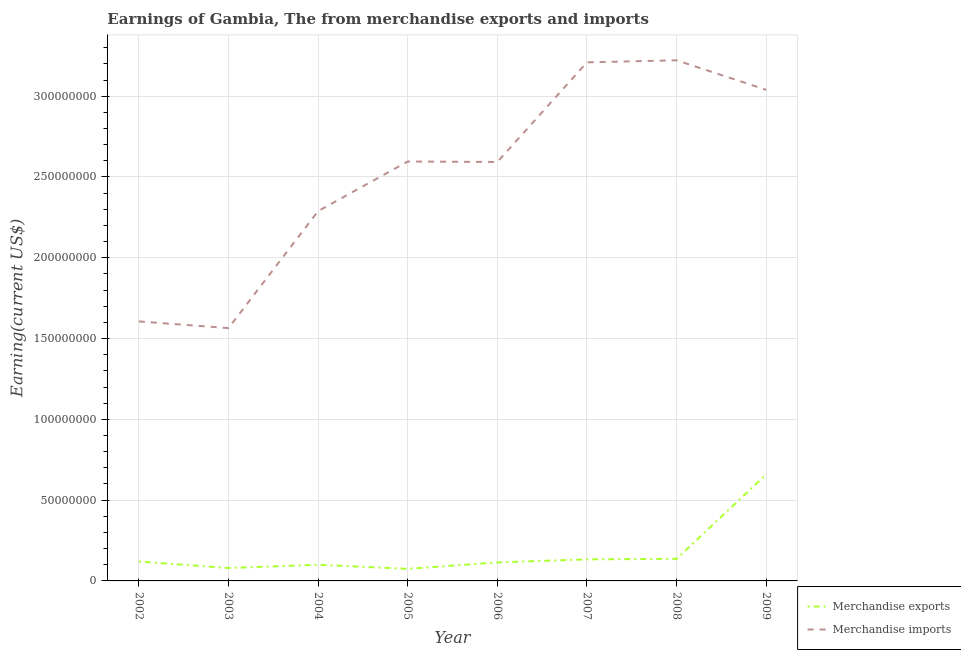Does the line corresponding to earnings from merchandise exports intersect with the line corresponding to earnings from merchandise imports?
Provide a short and direct response. No. What is the earnings from merchandise imports in 2006?
Your answer should be very brief. 2.59e+08. Across all years, what is the maximum earnings from merchandise imports?
Make the answer very short. 3.22e+08. Across all years, what is the minimum earnings from merchandise imports?
Offer a very short reply. 1.56e+08. In which year was the earnings from merchandise exports maximum?
Offer a terse response. 2009. In which year was the earnings from merchandise imports minimum?
Your response must be concise. 2003. What is the total earnings from merchandise imports in the graph?
Offer a terse response. 2.01e+09. What is the difference between the earnings from merchandise exports in 2004 and that in 2008?
Give a very brief answer. -3.67e+06. What is the difference between the earnings from merchandise imports in 2004 and the earnings from merchandise exports in 2008?
Provide a short and direct response. 2.15e+08. What is the average earnings from merchandise exports per year?
Make the answer very short. 1.77e+07. In the year 2004, what is the difference between the earnings from merchandise imports and earnings from merchandise exports?
Keep it short and to the point. 2.19e+08. What is the ratio of the earnings from merchandise exports in 2003 to that in 2004?
Ensure brevity in your answer.  0.8. Is the earnings from merchandise imports in 2008 less than that in 2009?
Make the answer very short. No. Is the difference between the earnings from merchandise exports in 2007 and 2008 greater than the difference between the earnings from merchandise imports in 2007 and 2008?
Offer a terse response. Yes. What is the difference between the highest and the second highest earnings from merchandise exports?
Your answer should be compact. 5.22e+07. What is the difference between the highest and the lowest earnings from merchandise exports?
Make the answer very short. 5.85e+07. In how many years, is the earnings from merchandise exports greater than the average earnings from merchandise exports taken over all years?
Give a very brief answer. 1. Does the earnings from merchandise imports monotonically increase over the years?
Your answer should be very brief. No. Is the earnings from merchandise exports strictly less than the earnings from merchandise imports over the years?
Keep it short and to the point. Yes. How many years are there in the graph?
Offer a very short reply. 8. How many legend labels are there?
Your response must be concise. 2. What is the title of the graph?
Provide a succinct answer. Earnings of Gambia, The from merchandise exports and imports. What is the label or title of the Y-axis?
Your answer should be compact. Earning(current US$). What is the Earning(current US$) in Merchandise exports in 2002?
Your response must be concise. 1.20e+07. What is the Earning(current US$) in Merchandise imports in 2002?
Provide a short and direct response. 1.61e+08. What is the Earning(current US$) in Merchandise imports in 2003?
Your answer should be very brief. 1.56e+08. What is the Earning(current US$) in Merchandise exports in 2004?
Your response must be concise. 1.00e+07. What is the Earning(current US$) in Merchandise imports in 2004?
Your answer should be compact. 2.29e+08. What is the Earning(current US$) of Merchandise exports in 2005?
Ensure brevity in your answer.  7.46e+06. What is the Earning(current US$) of Merchandise imports in 2005?
Give a very brief answer. 2.60e+08. What is the Earning(current US$) of Merchandise exports in 2006?
Provide a short and direct response. 1.15e+07. What is the Earning(current US$) of Merchandise imports in 2006?
Offer a terse response. 2.59e+08. What is the Earning(current US$) in Merchandise exports in 2007?
Your answer should be very brief. 1.33e+07. What is the Earning(current US$) of Merchandise imports in 2007?
Offer a terse response. 3.21e+08. What is the Earning(current US$) of Merchandise exports in 2008?
Provide a short and direct response. 1.37e+07. What is the Earning(current US$) of Merchandise imports in 2008?
Give a very brief answer. 3.22e+08. What is the Earning(current US$) in Merchandise exports in 2009?
Your answer should be compact. 6.59e+07. What is the Earning(current US$) in Merchandise imports in 2009?
Provide a short and direct response. 3.04e+08. Across all years, what is the maximum Earning(current US$) in Merchandise exports?
Your answer should be very brief. 6.59e+07. Across all years, what is the maximum Earning(current US$) in Merchandise imports?
Your answer should be very brief. 3.22e+08. Across all years, what is the minimum Earning(current US$) of Merchandise exports?
Offer a terse response. 7.46e+06. Across all years, what is the minimum Earning(current US$) of Merchandise imports?
Provide a succinct answer. 1.56e+08. What is the total Earning(current US$) of Merchandise exports in the graph?
Provide a short and direct response. 1.42e+08. What is the total Earning(current US$) in Merchandise imports in the graph?
Provide a short and direct response. 2.01e+09. What is the difference between the Earning(current US$) of Merchandise imports in 2002 and that in 2003?
Your answer should be very brief. 4.14e+06. What is the difference between the Earning(current US$) of Merchandise exports in 2002 and that in 2004?
Give a very brief answer. 2.00e+06. What is the difference between the Earning(current US$) in Merchandise imports in 2002 and that in 2004?
Provide a short and direct response. -6.83e+07. What is the difference between the Earning(current US$) in Merchandise exports in 2002 and that in 2005?
Offer a terse response. 4.54e+06. What is the difference between the Earning(current US$) in Merchandise imports in 2002 and that in 2005?
Make the answer very short. -9.90e+07. What is the difference between the Earning(current US$) of Merchandise exports in 2002 and that in 2006?
Make the answer very short. 5.37e+05. What is the difference between the Earning(current US$) in Merchandise imports in 2002 and that in 2006?
Make the answer very short. -9.87e+07. What is the difference between the Earning(current US$) in Merchandise exports in 2002 and that in 2007?
Ensure brevity in your answer.  -1.34e+06. What is the difference between the Earning(current US$) of Merchandise imports in 2002 and that in 2007?
Make the answer very short. -1.60e+08. What is the difference between the Earning(current US$) in Merchandise exports in 2002 and that in 2008?
Give a very brief answer. -1.67e+06. What is the difference between the Earning(current US$) of Merchandise imports in 2002 and that in 2008?
Offer a very short reply. -1.62e+08. What is the difference between the Earning(current US$) of Merchandise exports in 2002 and that in 2009?
Your answer should be very brief. -5.39e+07. What is the difference between the Earning(current US$) of Merchandise imports in 2002 and that in 2009?
Offer a very short reply. -1.43e+08. What is the difference between the Earning(current US$) in Merchandise exports in 2003 and that in 2004?
Provide a short and direct response. -2.00e+06. What is the difference between the Earning(current US$) in Merchandise imports in 2003 and that in 2004?
Give a very brief answer. -7.24e+07. What is the difference between the Earning(current US$) in Merchandise exports in 2003 and that in 2005?
Offer a terse response. 5.37e+05. What is the difference between the Earning(current US$) of Merchandise imports in 2003 and that in 2005?
Your response must be concise. -1.03e+08. What is the difference between the Earning(current US$) in Merchandise exports in 2003 and that in 2006?
Make the answer very short. -3.46e+06. What is the difference between the Earning(current US$) of Merchandise imports in 2003 and that in 2006?
Provide a succinct answer. -1.03e+08. What is the difference between the Earning(current US$) in Merchandise exports in 2003 and that in 2007?
Your answer should be very brief. -5.34e+06. What is the difference between the Earning(current US$) in Merchandise imports in 2003 and that in 2007?
Keep it short and to the point. -1.64e+08. What is the difference between the Earning(current US$) in Merchandise exports in 2003 and that in 2008?
Offer a terse response. -5.67e+06. What is the difference between the Earning(current US$) of Merchandise imports in 2003 and that in 2008?
Your response must be concise. -1.66e+08. What is the difference between the Earning(current US$) in Merchandise exports in 2003 and that in 2009?
Your answer should be very brief. -5.79e+07. What is the difference between the Earning(current US$) in Merchandise imports in 2003 and that in 2009?
Give a very brief answer. -1.47e+08. What is the difference between the Earning(current US$) of Merchandise exports in 2004 and that in 2005?
Your answer should be very brief. 2.54e+06. What is the difference between the Earning(current US$) of Merchandise imports in 2004 and that in 2005?
Ensure brevity in your answer.  -3.07e+07. What is the difference between the Earning(current US$) of Merchandise exports in 2004 and that in 2006?
Keep it short and to the point. -1.46e+06. What is the difference between the Earning(current US$) in Merchandise imports in 2004 and that in 2006?
Your response must be concise. -3.04e+07. What is the difference between the Earning(current US$) in Merchandise exports in 2004 and that in 2007?
Give a very brief answer. -3.34e+06. What is the difference between the Earning(current US$) of Merchandise imports in 2004 and that in 2007?
Offer a very short reply. -9.21e+07. What is the difference between the Earning(current US$) of Merchandise exports in 2004 and that in 2008?
Your response must be concise. -3.67e+06. What is the difference between the Earning(current US$) in Merchandise imports in 2004 and that in 2008?
Offer a terse response. -9.33e+07. What is the difference between the Earning(current US$) of Merchandise exports in 2004 and that in 2009?
Keep it short and to the point. -5.59e+07. What is the difference between the Earning(current US$) of Merchandise imports in 2004 and that in 2009?
Your answer should be compact. -7.51e+07. What is the difference between the Earning(current US$) in Merchandise exports in 2005 and that in 2006?
Your answer should be compact. -4.00e+06. What is the difference between the Earning(current US$) of Merchandise imports in 2005 and that in 2006?
Offer a terse response. 2.91e+05. What is the difference between the Earning(current US$) of Merchandise exports in 2005 and that in 2007?
Offer a terse response. -5.87e+06. What is the difference between the Earning(current US$) of Merchandise imports in 2005 and that in 2007?
Keep it short and to the point. -6.14e+07. What is the difference between the Earning(current US$) in Merchandise exports in 2005 and that in 2008?
Your answer should be very brief. -6.21e+06. What is the difference between the Earning(current US$) in Merchandise imports in 2005 and that in 2008?
Make the answer very short. -6.26e+07. What is the difference between the Earning(current US$) of Merchandise exports in 2005 and that in 2009?
Make the answer very short. -5.85e+07. What is the difference between the Earning(current US$) in Merchandise imports in 2005 and that in 2009?
Keep it short and to the point. -4.44e+07. What is the difference between the Earning(current US$) in Merchandise exports in 2006 and that in 2007?
Ensure brevity in your answer.  -1.87e+06. What is the difference between the Earning(current US$) of Merchandise imports in 2006 and that in 2007?
Provide a succinct answer. -6.17e+07. What is the difference between the Earning(current US$) of Merchandise exports in 2006 and that in 2008?
Give a very brief answer. -2.21e+06. What is the difference between the Earning(current US$) of Merchandise imports in 2006 and that in 2008?
Ensure brevity in your answer.  -6.29e+07. What is the difference between the Earning(current US$) of Merchandise exports in 2006 and that in 2009?
Offer a very short reply. -5.45e+07. What is the difference between the Earning(current US$) in Merchandise imports in 2006 and that in 2009?
Make the answer very short. -4.47e+07. What is the difference between the Earning(current US$) of Merchandise exports in 2007 and that in 2008?
Your answer should be compact. -3.33e+05. What is the difference between the Earning(current US$) in Merchandise imports in 2007 and that in 2008?
Make the answer very short. -1.27e+06. What is the difference between the Earning(current US$) in Merchandise exports in 2007 and that in 2009?
Make the answer very short. -5.26e+07. What is the difference between the Earning(current US$) in Merchandise imports in 2007 and that in 2009?
Offer a terse response. 1.70e+07. What is the difference between the Earning(current US$) of Merchandise exports in 2008 and that in 2009?
Ensure brevity in your answer.  -5.22e+07. What is the difference between the Earning(current US$) of Merchandise imports in 2008 and that in 2009?
Offer a very short reply. 1.83e+07. What is the difference between the Earning(current US$) of Merchandise exports in 2002 and the Earning(current US$) of Merchandise imports in 2003?
Provide a short and direct response. -1.44e+08. What is the difference between the Earning(current US$) in Merchandise exports in 2002 and the Earning(current US$) in Merchandise imports in 2004?
Offer a terse response. -2.17e+08. What is the difference between the Earning(current US$) of Merchandise exports in 2002 and the Earning(current US$) of Merchandise imports in 2005?
Make the answer very short. -2.48e+08. What is the difference between the Earning(current US$) in Merchandise exports in 2002 and the Earning(current US$) in Merchandise imports in 2006?
Provide a short and direct response. -2.47e+08. What is the difference between the Earning(current US$) in Merchandise exports in 2002 and the Earning(current US$) in Merchandise imports in 2007?
Offer a terse response. -3.09e+08. What is the difference between the Earning(current US$) in Merchandise exports in 2002 and the Earning(current US$) in Merchandise imports in 2008?
Give a very brief answer. -3.10e+08. What is the difference between the Earning(current US$) of Merchandise exports in 2002 and the Earning(current US$) of Merchandise imports in 2009?
Provide a short and direct response. -2.92e+08. What is the difference between the Earning(current US$) of Merchandise exports in 2003 and the Earning(current US$) of Merchandise imports in 2004?
Provide a succinct answer. -2.21e+08. What is the difference between the Earning(current US$) of Merchandise exports in 2003 and the Earning(current US$) of Merchandise imports in 2005?
Give a very brief answer. -2.52e+08. What is the difference between the Earning(current US$) of Merchandise exports in 2003 and the Earning(current US$) of Merchandise imports in 2006?
Offer a terse response. -2.51e+08. What is the difference between the Earning(current US$) of Merchandise exports in 2003 and the Earning(current US$) of Merchandise imports in 2007?
Give a very brief answer. -3.13e+08. What is the difference between the Earning(current US$) of Merchandise exports in 2003 and the Earning(current US$) of Merchandise imports in 2008?
Your response must be concise. -3.14e+08. What is the difference between the Earning(current US$) of Merchandise exports in 2003 and the Earning(current US$) of Merchandise imports in 2009?
Provide a short and direct response. -2.96e+08. What is the difference between the Earning(current US$) of Merchandise exports in 2004 and the Earning(current US$) of Merchandise imports in 2005?
Offer a very short reply. -2.50e+08. What is the difference between the Earning(current US$) of Merchandise exports in 2004 and the Earning(current US$) of Merchandise imports in 2006?
Give a very brief answer. -2.49e+08. What is the difference between the Earning(current US$) of Merchandise exports in 2004 and the Earning(current US$) of Merchandise imports in 2007?
Offer a terse response. -3.11e+08. What is the difference between the Earning(current US$) in Merchandise exports in 2004 and the Earning(current US$) in Merchandise imports in 2008?
Your answer should be compact. -3.12e+08. What is the difference between the Earning(current US$) in Merchandise exports in 2004 and the Earning(current US$) in Merchandise imports in 2009?
Your answer should be very brief. -2.94e+08. What is the difference between the Earning(current US$) of Merchandise exports in 2005 and the Earning(current US$) of Merchandise imports in 2006?
Offer a very short reply. -2.52e+08. What is the difference between the Earning(current US$) of Merchandise exports in 2005 and the Earning(current US$) of Merchandise imports in 2007?
Keep it short and to the point. -3.13e+08. What is the difference between the Earning(current US$) in Merchandise exports in 2005 and the Earning(current US$) in Merchandise imports in 2008?
Keep it short and to the point. -3.15e+08. What is the difference between the Earning(current US$) in Merchandise exports in 2005 and the Earning(current US$) in Merchandise imports in 2009?
Offer a very short reply. -2.96e+08. What is the difference between the Earning(current US$) of Merchandise exports in 2006 and the Earning(current US$) of Merchandise imports in 2007?
Provide a succinct answer. -3.09e+08. What is the difference between the Earning(current US$) in Merchandise exports in 2006 and the Earning(current US$) in Merchandise imports in 2008?
Make the answer very short. -3.11e+08. What is the difference between the Earning(current US$) in Merchandise exports in 2006 and the Earning(current US$) in Merchandise imports in 2009?
Make the answer very short. -2.92e+08. What is the difference between the Earning(current US$) of Merchandise exports in 2007 and the Earning(current US$) of Merchandise imports in 2008?
Keep it short and to the point. -3.09e+08. What is the difference between the Earning(current US$) in Merchandise exports in 2007 and the Earning(current US$) in Merchandise imports in 2009?
Your answer should be very brief. -2.91e+08. What is the difference between the Earning(current US$) of Merchandise exports in 2008 and the Earning(current US$) of Merchandise imports in 2009?
Your answer should be very brief. -2.90e+08. What is the average Earning(current US$) of Merchandise exports per year?
Make the answer very short. 1.77e+07. What is the average Earning(current US$) in Merchandise imports per year?
Make the answer very short. 2.51e+08. In the year 2002, what is the difference between the Earning(current US$) in Merchandise exports and Earning(current US$) in Merchandise imports?
Ensure brevity in your answer.  -1.49e+08. In the year 2003, what is the difference between the Earning(current US$) of Merchandise exports and Earning(current US$) of Merchandise imports?
Your answer should be compact. -1.48e+08. In the year 2004, what is the difference between the Earning(current US$) of Merchandise exports and Earning(current US$) of Merchandise imports?
Offer a very short reply. -2.19e+08. In the year 2005, what is the difference between the Earning(current US$) in Merchandise exports and Earning(current US$) in Merchandise imports?
Provide a succinct answer. -2.52e+08. In the year 2006, what is the difference between the Earning(current US$) in Merchandise exports and Earning(current US$) in Merchandise imports?
Provide a succinct answer. -2.48e+08. In the year 2007, what is the difference between the Earning(current US$) of Merchandise exports and Earning(current US$) of Merchandise imports?
Your answer should be compact. -3.08e+08. In the year 2008, what is the difference between the Earning(current US$) in Merchandise exports and Earning(current US$) in Merchandise imports?
Offer a terse response. -3.09e+08. In the year 2009, what is the difference between the Earning(current US$) of Merchandise exports and Earning(current US$) of Merchandise imports?
Make the answer very short. -2.38e+08. What is the ratio of the Earning(current US$) of Merchandise exports in 2002 to that in 2003?
Provide a short and direct response. 1.5. What is the ratio of the Earning(current US$) in Merchandise imports in 2002 to that in 2003?
Make the answer very short. 1.03. What is the ratio of the Earning(current US$) of Merchandise exports in 2002 to that in 2004?
Offer a terse response. 1.2. What is the ratio of the Earning(current US$) of Merchandise imports in 2002 to that in 2004?
Make the answer very short. 0.7. What is the ratio of the Earning(current US$) in Merchandise exports in 2002 to that in 2005?
Make the answer very short. 1.61. What is the ratio of the Earning(current US$) in Merchandise imports in 2002 to that in 2005?
Give a very brief answer. 0.62. What is the ratio of the Earning(current US$) of Merchandise exports in 2002 to that in 2006?
Offer a very short reply. 1.05. What is the ratio of the Earning(current US$) of Merchandise imports in 2002 to that in 2006?
Provide a succinct answer. 0.62. What is the ratio of the Earning(current US$) of Merchandise exports in 2002 to that in 2007?
Your answer should be very brief. 0.9. What is the ratio of the Earning(current US$) in Merchandise imports in 2002 to that in 2007?
Provide a succinct answer. 0.5. What is the ratio of the Earning(current US$) in Merchandise exports in 2002 to that in 2008?
Offer a terse response. 0.88. What is the ratio of the Earning(current US$) of Merchandise imports in 2002 to that in 2008?
Keep it short and to the point. 0.5. What is the ratio of the Earning(current US$) of Merchandise exports in 2002 to that in 2009?
Make the answer very short. 0.18. What is the ratio of the Earning(current US$) in Merchandise imports in 2002 to that in 2009?
Offer a terse response. 0.53. What is the ratio of the Earning(current US$) of Merchandise exports in 2003 to that in 2004?
Your answer should be compact. 0.8. What is the ratio of the Earning(current US$) in Merchandise imports in 2003 to that in 2004?
Your response must be concise. 0.68. What is the ratio of the Earning(current US$) in Merchandise exports in 2003 to that in 2005?
Provide a succinct answer. 1.07. What is the ratio of the Earning(current US$) in Merchandise imports in 2003 to that in 2005?
Your answer should be compact. 0.6. What is the ratio of the Earning(current US$) in Merchandise exports in 2003 to that in 2006?
Your answer should be very brief. 0.7. What is the ratio of the Earning(current US$) in Merchandise imports in 2003 to that in 2006?
Your answer should be very brief. 0.6. What is the ratio of the Earning(current US$) in Merchandise exports in 2003 to that in 2007?
Your answer should be compact. 0.6. What is the ratio of the Earning(current US$) in Merchandise imports in 2003 to that in 2007?
Your response must be concise. 0.49. What is the ratio of the Earning(current US$) in Merchandise exports in 2003 to that in 2008?
Offer a terse response. 0.59. What is the ratio of the Earning(current US$) in Merchandise imports in 2003 to that in 2008?
Offer a terse response. 0.49. What is the ratio of the Earning(current US$) of Merchandise exports in 2003 to that in 2009?
Offer a terse response. 0.12. What is the ratio of the Earning(current US$) of Merchandise imports in 2003 to that in 2009?
Your answer should be compact. 0.51. What is the ratio of the Earning(current US$) in Merchandise exports in 2004 to that in 2005?
Make the answer very short. 1.34. What is the ratio of the Earning(current US$) in Merchandise imports in 2004 to that in 2005?
Provide a short and direct response. 0.88. What is the ratio of the Earning(current US$) in Merchandise exports in 2004 to that in 2006?
Your answer should be compact. 0.87. What is the ratio of the Earning(current US$) in Merchandise imports in 2004 to that in 2006?
Give a very brief answer. 0.88. What is the ratio of the Earning(current US$) of Merchandise exports in 2004 to that in 2007?
Make the answer very short. 0.75. What is the ratio of the Earning(current US$) of Merchandise imports in 2004 to that in 2007?
Provide a short and direct response. 0.71. What is the ratio of the Earning(current US$) of Merchandise exports in 2004 to that in 2008?
Offer a very short reply. 0.73. What is the ratio of the Earning(current US$) in Merchandise imports in 2004 to that in 2008?
Ensure brevity in your answer.  0.71. What is the ratio of the Earning(current US$) of Merchandise exports in 2004 to that in 2009?
Ensure brevity in your answer.  0.15. What is the ratio of the Earning(current US$) of Merchandise imports in 2004 to that in 2009?
Make the answer very short. 0.75. What is the ratio of the Earning(current US$) of Merchandise exports in 2005 to that in 2006?
Provide a short and direct response. 0.65. What is the ratio of the Earning(current US$) in Merchandise exports in 2005 to that in 2007?
Keep it short and to the point. 0.56. What is the ratio of the Earning(current US$) of Merchandise imports in 2005 to that in 2007?
Make the answer very short. 0.81. What is the ratio of the Earning(current US$) in Merchandise exports in 2005 to that in 2008?
Provide a short and direct response. 0.55. What is the ratio of the Earning(current US$) of Merchandise imports in 2005 to that in 2008?
Your answer should be compact. 0.81. What is the ratio of the Earning(current US$) of Merchandise exports in 2005 to that in 2009?
Provide a short and direct response. 0.11. What is the ratio of the Earning(current US$) in Merchandise imports in 2005 to that in 2009?
Your answer should be compact. 0.85. What is the ratio of the Earning(current US$) of Merchandise exports in 2006 to that in 2007?
Give a very brief answer. 0.86. What is the ratio of the Earning(current US$) of Merchandise imports in 2006 to that in 2007?
Offer a terse response. 0.81. What is the ratio of the Earning(current US$) in Merchandise exports in 2006 to that in 2008?
Keep it short and to the point. 0.84. What is the ratio of the Earning(current US$) of Merchandise imports in 2006 to that in 2008?
Make the answer very short. 0.8. What is the ratio of the Earning(current US$) in Merchandise exports in 2006 to that in 2009?
Your response must be concise. 0.17. What is the ratio of the Earning(current US$) in Merchandise imports in 2006 to that in 2009?
Provide a succinct answer. 0.85. What is the ratio of the Earning(current US$) in Merchandise exports in 2007 to that in 2008?
Keep it short and to the point. 0.98. What is the ratio of the Earning(current US$) in Merchandise imports in 2007 to that in 2008?
Your answer should be compact. 1. What is the ratio of the Earning(current US$) of Merchandise exports in 2007 to that in 2009?
Offer a very short reply. 0.2. What is the ratio of the Earning(current US$) of Merchandise imports in 2007 to that in 2009?
Your answer should be compact. 1.06. What is the ratio of the Earning(current US$) in Merchandise exports in 2008 to that in 2009?
Ensure brevity in your answer.  0.21. What is the ratio of the Earning(current US$) in Merchandise imports in 2008 to that in 2009?
Keep it short and to the point. 1.06. What is the difference between the highest and the second highest Earning(current US$) of Merchandise exports?
Make the answer very short. 5.22e+07. What is the difference between the highest and the second highest Earning(current US$) in Merchandise imports?
Keep it short and to the point. 1.27e+06. What is the difference between the highest and the lowest Earning(current US$) in Merchandise exports?
Provide a succinct answer. 5.85e+07. What is the difference between the highest and the lowest Earning(current US$) in Merchandise imports?
Provide a short and direct response. 1.66e+08. 